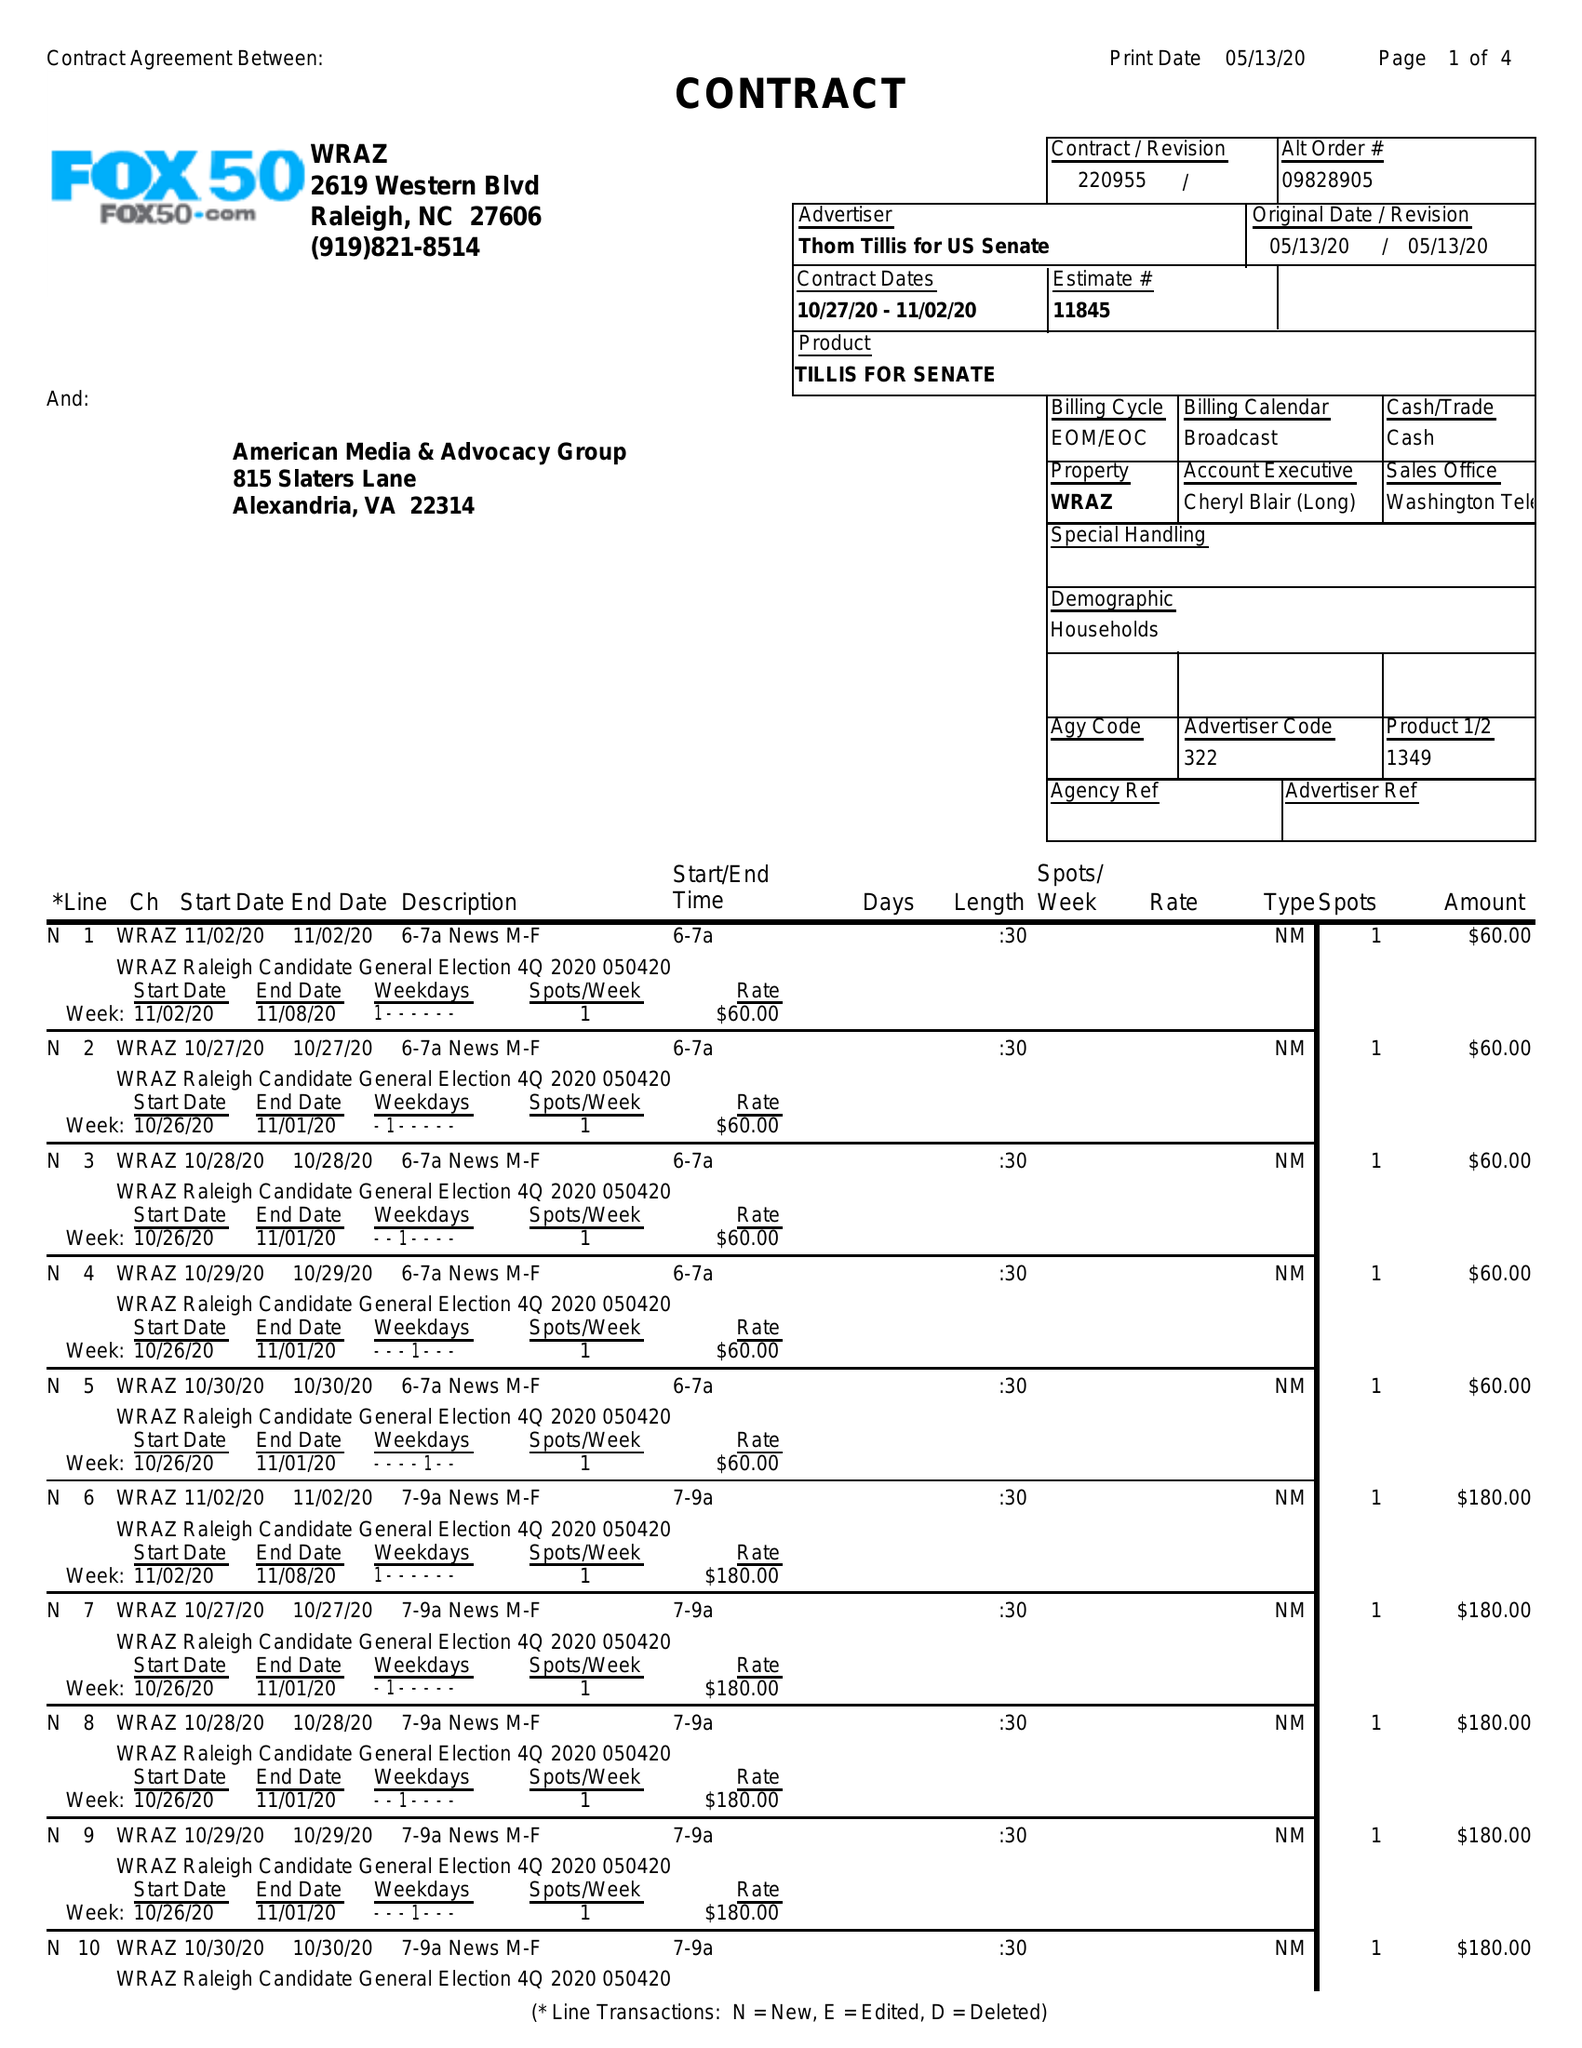What is the value for the flight_to?
Answer the question using a single word or phrase. 11/02/20 